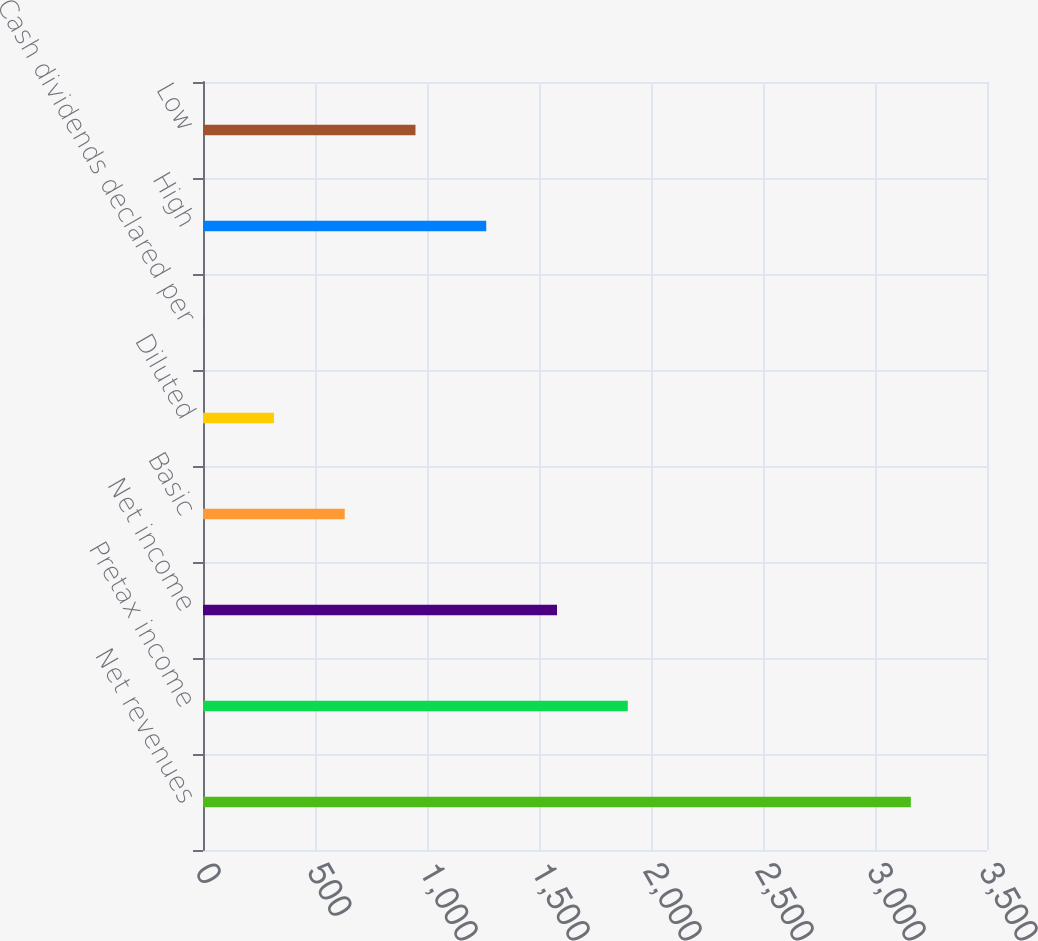Convert chart to OTSL. <chart><loc_0><loc_0><loc_500><loc_500><bar_chart><fcel>Net revenues<fcel>Pretax income<fcel>Net income<fcel>Basic<fcel>Diluted<fcel>Cash dividends declared per<fcel>High<fcel>Low<nl><fcel>3160<fcel>1896.35<fcel>1580.43<fcel>632.67<fcel>316.75<fcel>0.83<fcel>1264.51<fcel>948.59<nl></chart> 